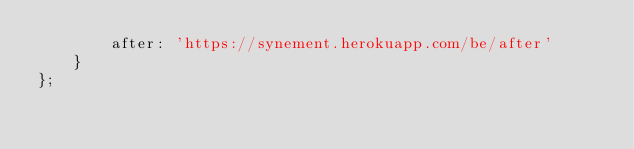Convert code to text. <code><loc_0><loc_0><loc_500><loc_500><_TypeScript_>        after: 'https://synement.herokuapp.com/be/after'
    }
};
</code> 